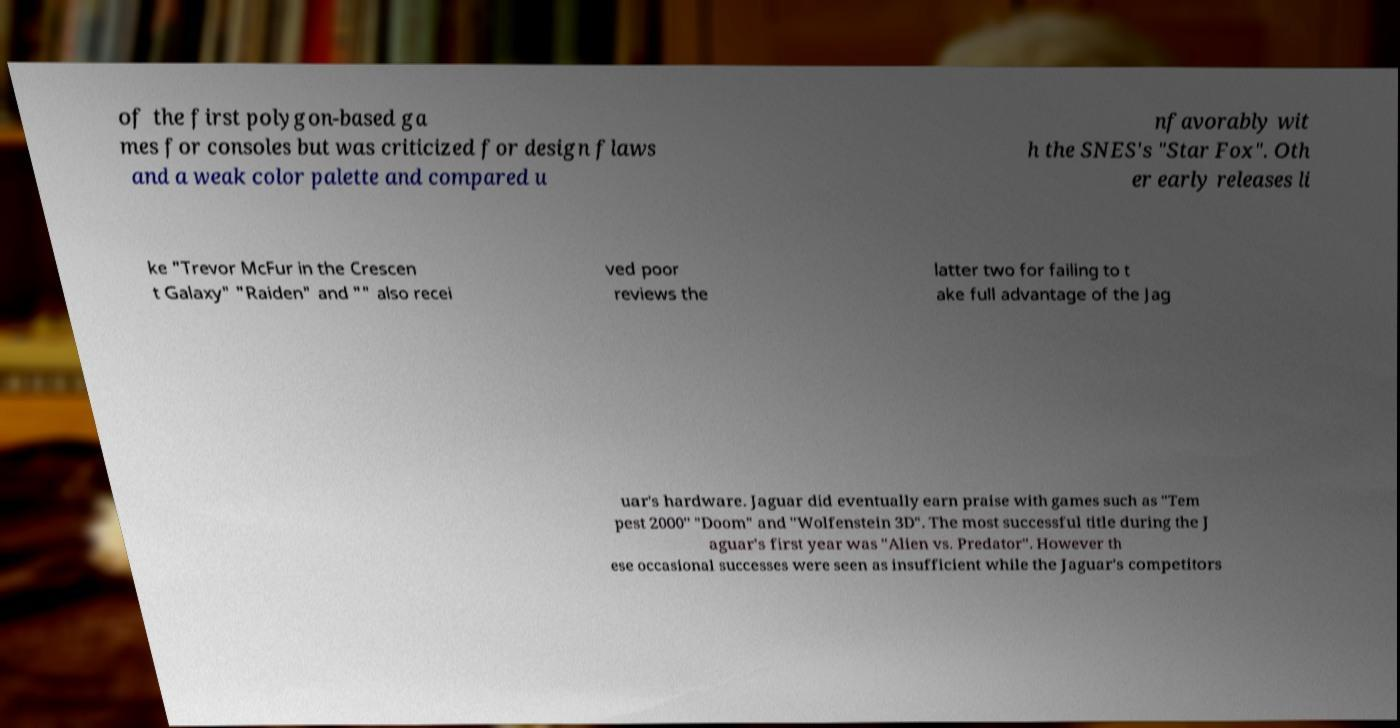I need the written content from this picture converted into text. Can you do that? of the first polygon-based ga mes for consoles but was criticized for design flaws and a weak color palette and compared u nfavorably wit h the SNES's "Star Fox". Oth er early releases li ke "Trevor McFur in the Crescen t Galaxy" "Raiden" and "" also recei ved poor reviews the latter two for failing to t ake full advantage of the Jag uar's hardware. Jaguar did eventually earn praise with games such as "Tem pest 2000" "Doom" and "Wolfenstein 3D". The most successful title during the J aguar's first year was "Alien vs. Predator". However th ese occasional successes were seen as insufficient while the Jaguar's competitors 